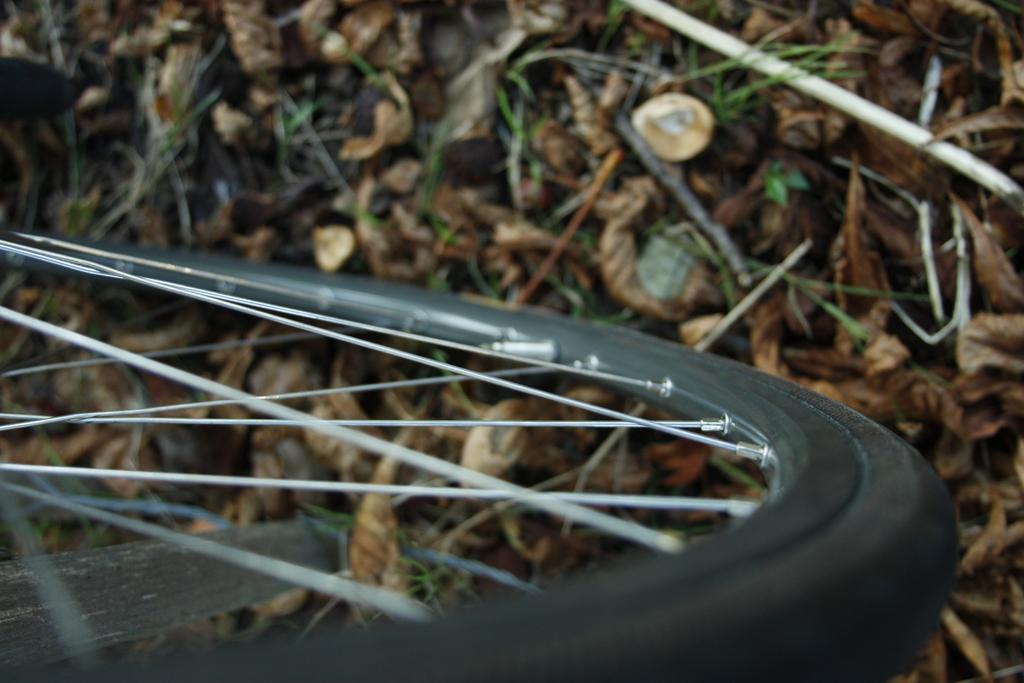In one or two sentences, can you explain what this image depicts? In this picture in the front there is a tyre. In the background there are dry leaves. 